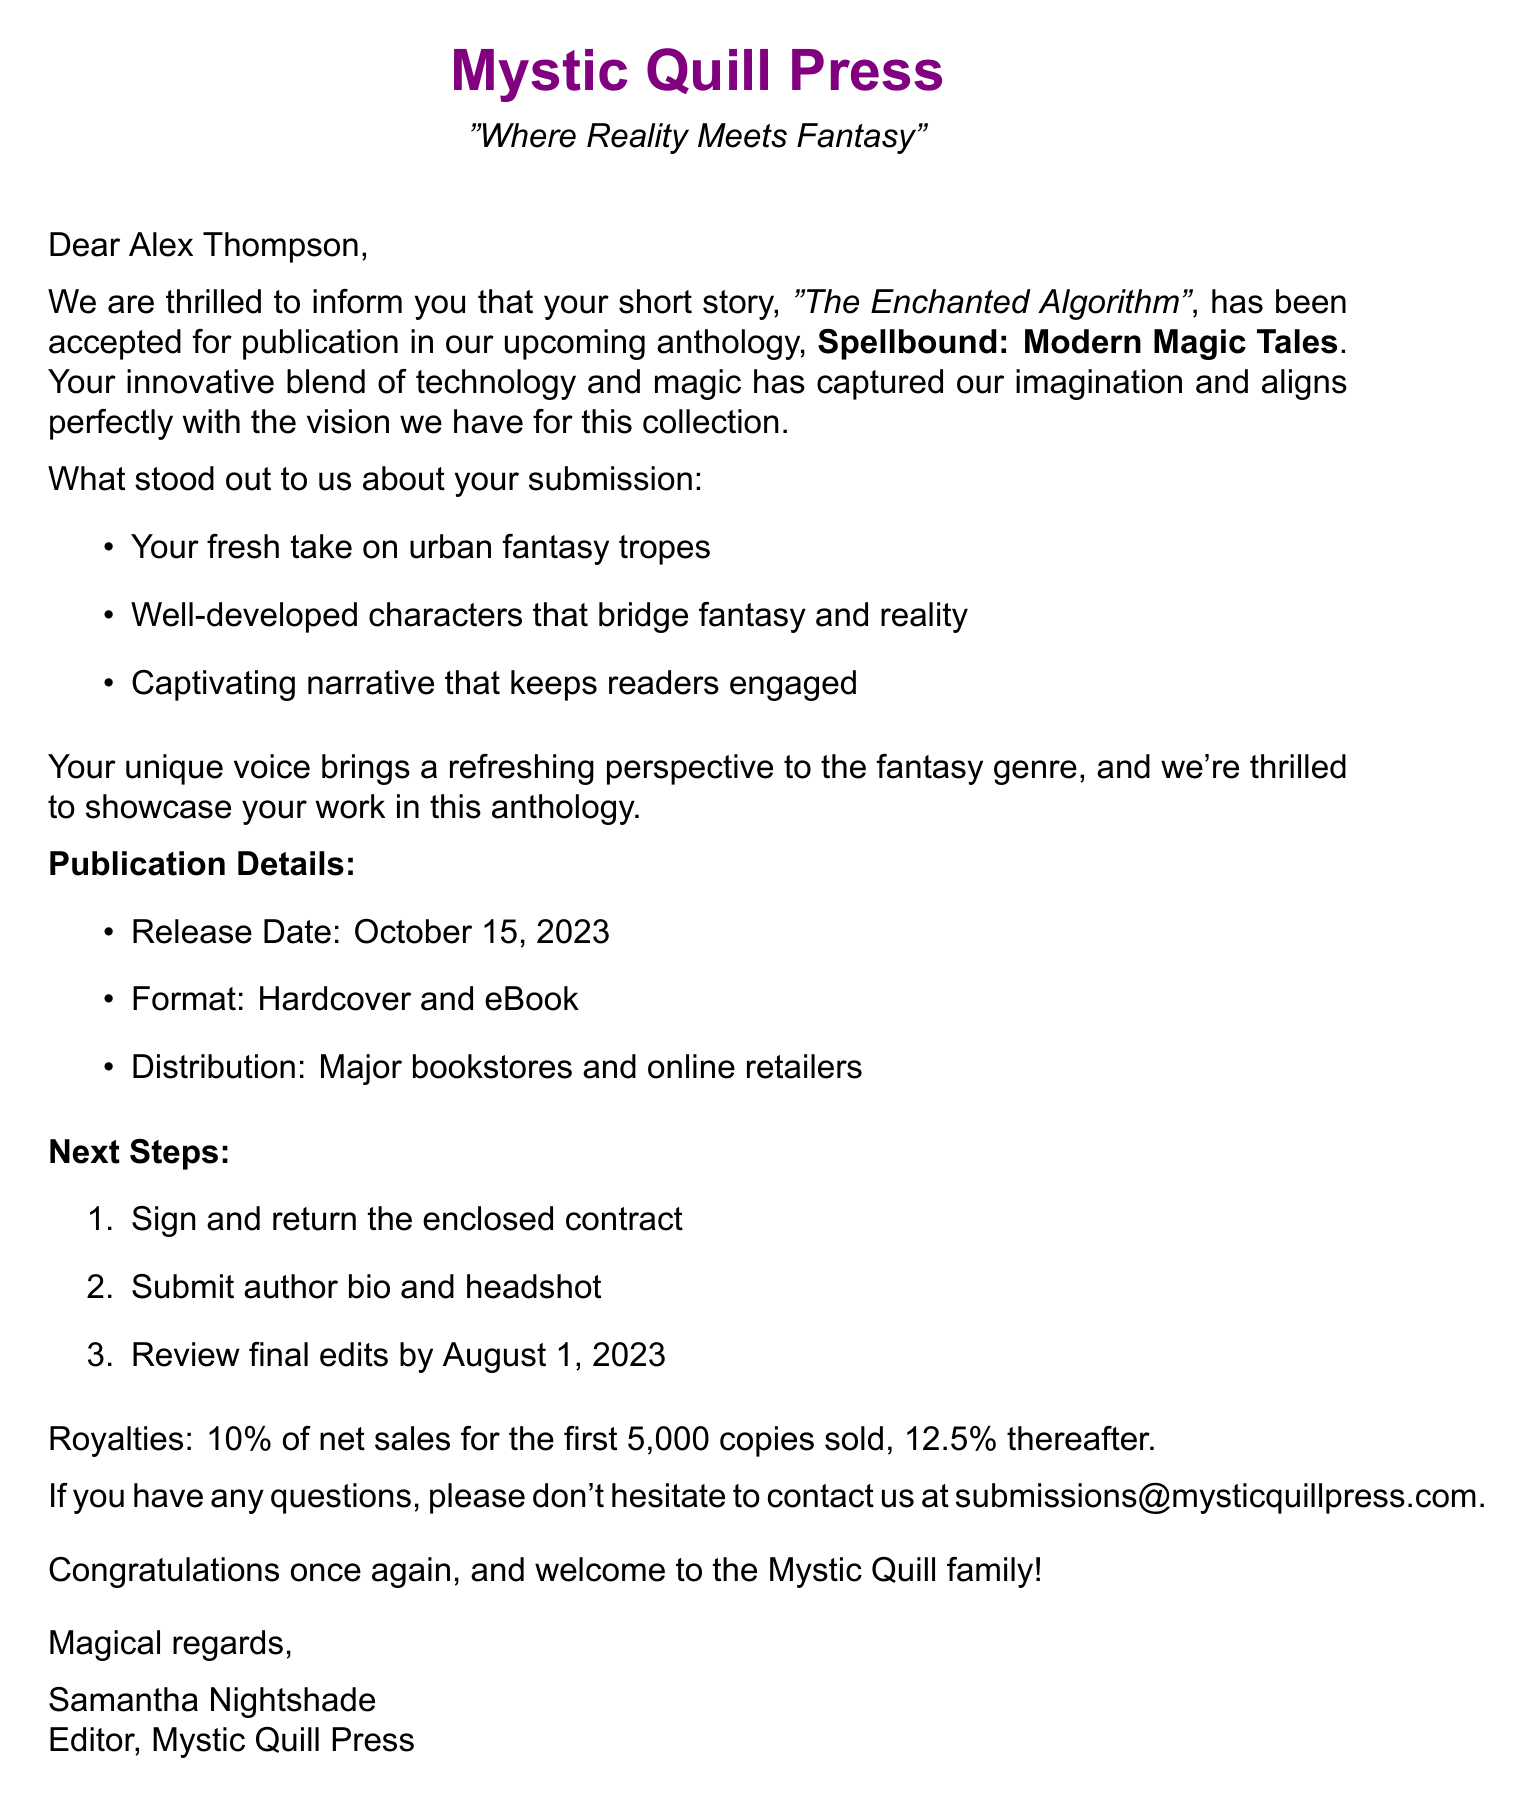What is the recipient's name? The recipient's name is given at the beginning of the letter.
Answer: Alex Thompson What is the title of the anthology? The title of the anthology is explicitly stated in the acceptance letter.
Answer: Spellbound: Modern Magic Tales Who is the editor of the publishing house? The editor's name is mentioned in the closing of the letter.
Answer: Samantha Nightshade What is the release date of the anthology? The release date is specified in the publication details section of the document.
Answer: October 15, 2023 What percentage of sales is offered as royalties for the first 5,000 copies sold? The document provides specific royalty information in the royalties section.
Answer: 10% What is one of the praise points for the story? The document lists key praises about the story in bullet points.
Answer: Innovative blend of technology and magic What are the next steps listed in the acceptance letter? The next steps are outlined in a numbered list in the document.
Answer: Sign and return the enclosed contract Which format will the anthology be available in? The formats available for the anthology are mentioned under publication details.
Answer: Hardcover and eBook What is the email address for contact? The document includes a contact email for further inquiries.
Answer: submissions@mysticquillpress.com 